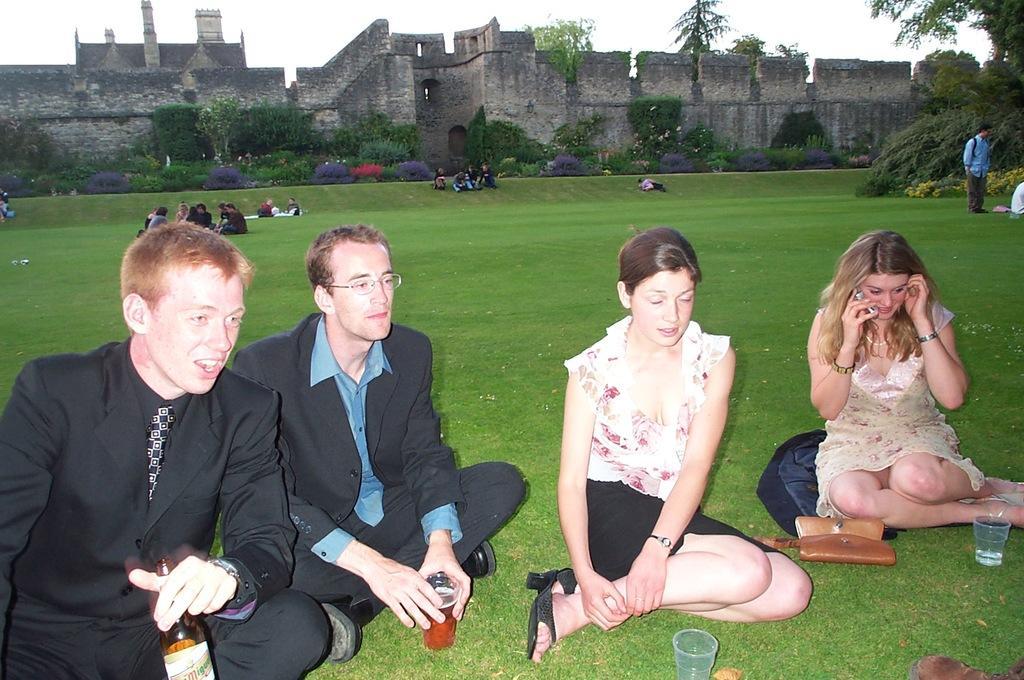Describe this image in one or two sentences. In this image we can see a grass lawn. There are many people sitting. One person is holding a bottle. There are glasses. Also there is purse. In the back there is a building. Also there are trees. And there is sky. 